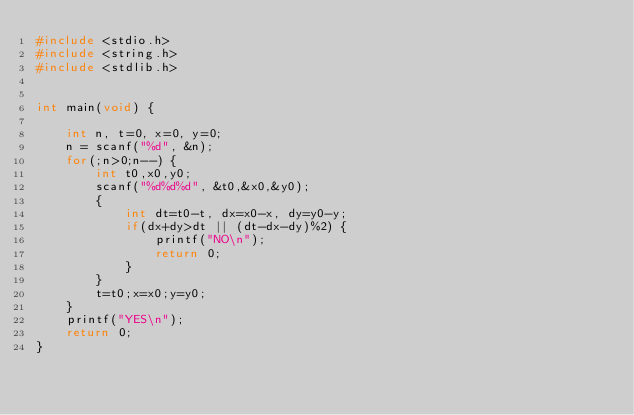Convert code to text. <code><loc_0><loc_0><loc_500><loc_500><_C_>#include <stdio.h>
#include <string.h>
#include <stdlib.h>


int main(void) {
    
    int n, t=0, x=0, y=0;
    n = scanf("%d", &n);
    for(;n>0;n--) {
        int t0,x0,y0;
        scanf("%d%d%d", &t0,&x0,&y0);
        {
            int dt=t0-t, dx=x0-x, dy=y0-y;
            if(dx+dy>dt || (dt-dx-dy)%2) {
                printf("NO\n");
                return 0;
            }
        }
        t=t0;x=x0;y=y0;
    }
    printf("YES\n");
    return 0;
}</code> 